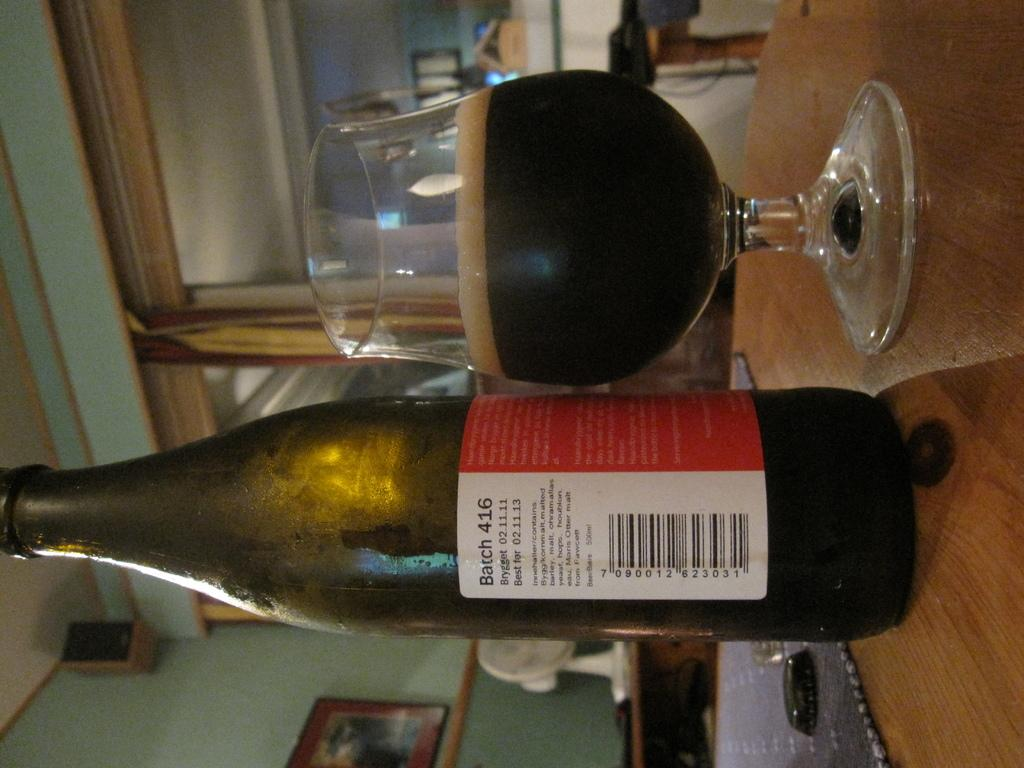<image>
Share a concise interpretation of the image provided. A bottle from batch 416, best for 02.11.13 sits on a table next to a glass of the same liquid. 